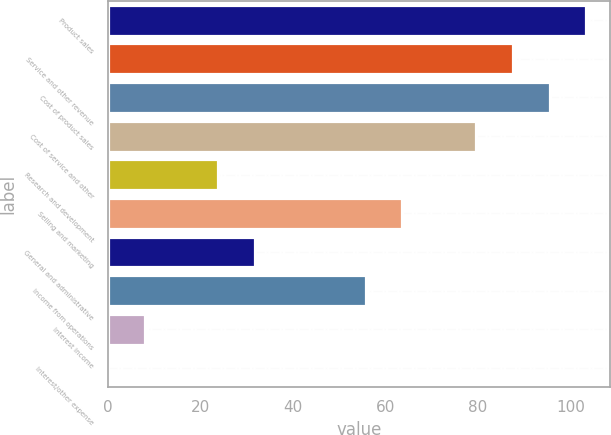Convert chart to OTSL. <chart><loc_0><loc_0><loc_500><loc_500><bar_chart><fcel>Product sales<fcel>Service and other revenue<fcel>Cost of product sales<fcel>Cost of service and other<fcel>Research and development<fcel>Selling and marketing<fcel>General and administrative<fcel>Income from operations<fcel>Interest income<fcel>Interest/other expense<nl><fcel>103.45<fcel>87.55<fcel>95.5<fcel>79.6<fcel>23.95<fcel>63.7<fcel>31.9<fcel>55.75<fcel>8.05<fcel>0.1<nl></chart> 